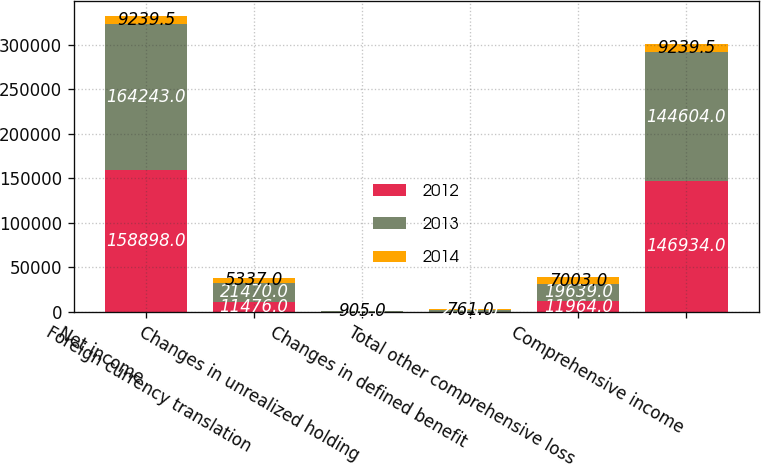<chart> <loc_0><loc_0><loc_500><loc_500><stacked_bar_chart><ecel><fcel>Net income<fcel>Foreign currency translation<fcel>Changes in unrealized holding<fcel>Changes in defined benefit<fcel>Total other comprehensive loss<fcel>Comprehensive income<nl><fcel>2012<fcel>158898<fcel>11476<fcel>305<fcel>183<fcel>11964<fcel>146934<nl><fcel>2013<fcel>164243<fcel>21470<fcel>180<fcel>2011<fcel>19639<fcel>144604<nl><fcel>2014<fcel>9239.5<fcel>5337<fcel>905<fcel>761<fcel>7003<fcel>9239.5<nl></chart> 